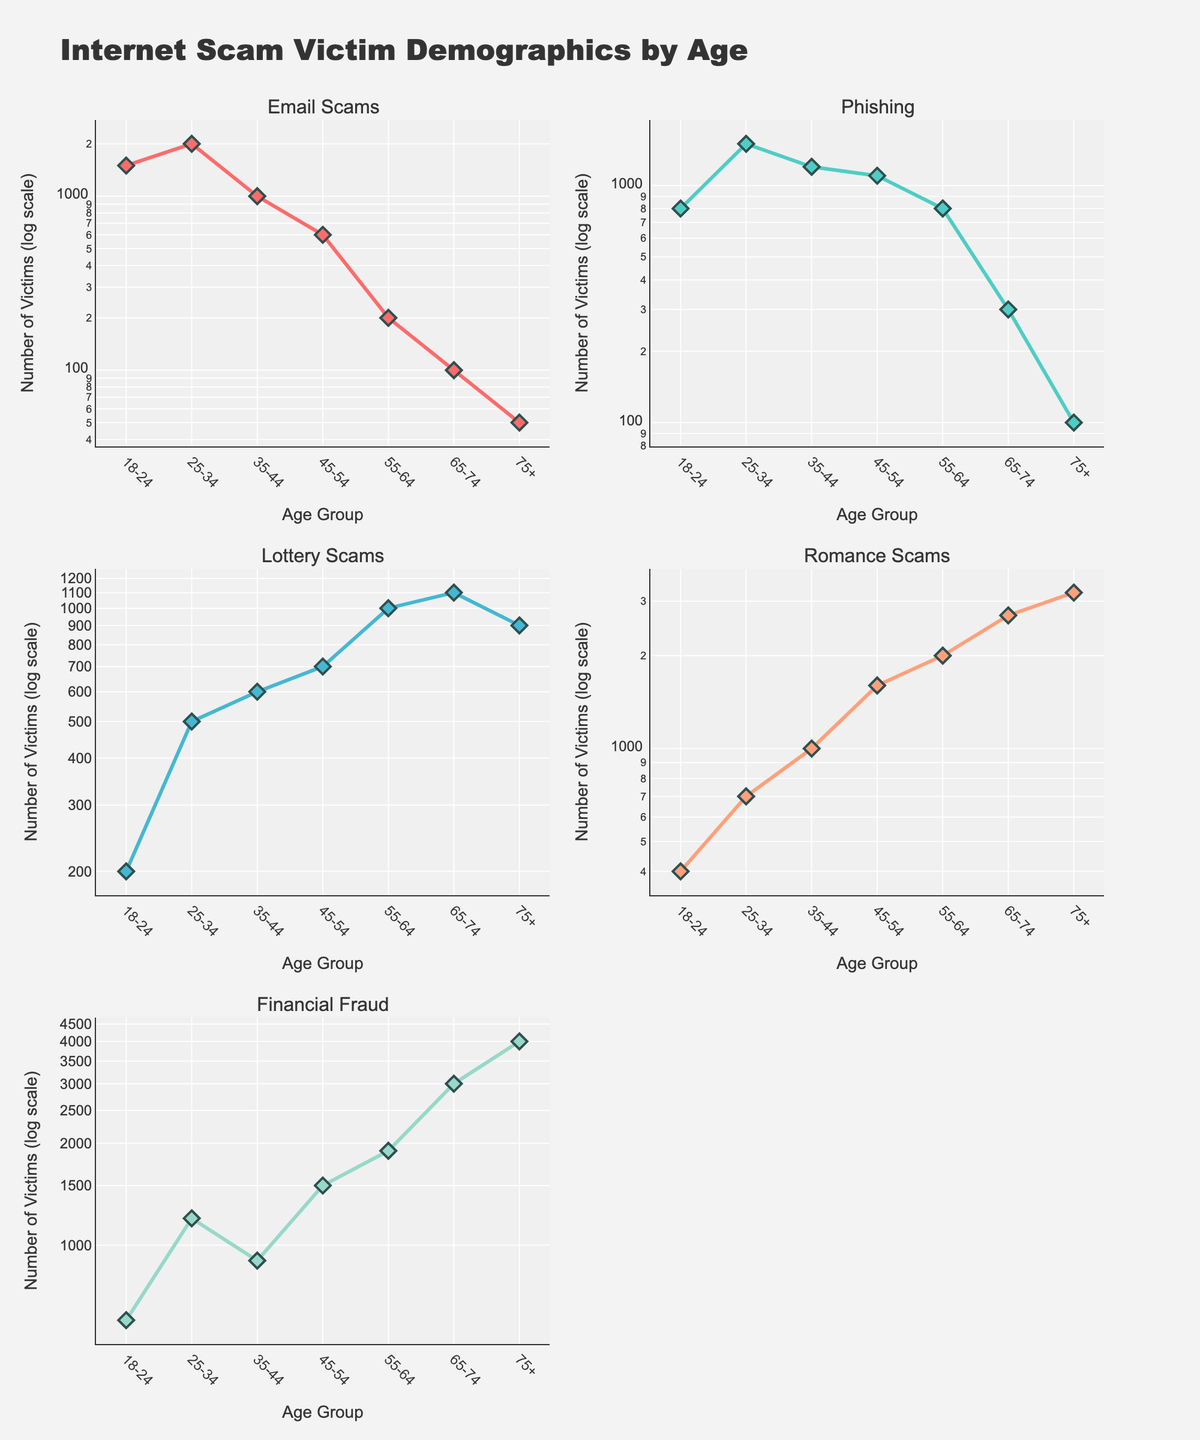What are the age groups displayed in the figure? The x-axis of the figure represents different age groups, which can be read directly: 18-24, 25-34, 35-44, 45-54, 55-64, 65-74, and 75+.
Answer: 18-24, 25-34, 35-44, 45-54, 55-64, 65-74, 75+ Which age group has the highest count of Email Scam victims? By looking at the subplot for Email Scams, we can see the highest y-value corresponds to the 25-34 age group.
Answer: 25-34 What is the log scale value of Financial Fraud victims for the age group 65-74? Locate the subplot for Financial Fraud, find the data point for the age group 65-74, which approximately corresponds to 3000 on the log scale.
Answer: 3000 For which scam type is the number of victims consistently increasing as the age group increases? By examining each subplot, Romance Scams shows a consistent increase in the number of victims as age increases from the 18-24 to the 75+ age group.
Answer: Romance Scams How does the number of victims of Phishing in the 45-54 age group compare to the 55-64 age group? Check the Phishing subplot and compare the y-values for the 45-54 and 55-64 age groups; 45-54 has a slightly higher value.
Answer: 45-54 is higher Which scam type has the least number of victims in the 18-24 age group? Look at each subplot and find the smallest y-value for the 18-24 age group; Lottery Scams has the least number with 200 victims.
Answer: Lottery Scams What is the difference in the number of victims of Romance Scams between the 35-44 and 45-54 age groups? Locate the subplot for Romance Scams, then subtract the y-value for 35-44 (1000) from 45-54 (1600) to get the difference.
Answer: 600 What trend can be observed in Lottery Scams for the age groups 55-64 and 65-74? Observe the Lottery Scams subplot where there is an increase in the number of victims from 55-64 (1000) to 65-74 (1100).
Answer: Increasing Compare the number of Financial Fraud victims between the 55-64 and 75+ age groups. In the Financial Fraud subplot, compare the y-values for 55-64 (1900) and 75+ (4000); 75+ has more victims.
Answer: 75+ is higher Which age group has the highest victim count across all the scam types combined? By summing up the number of victims for each scam type within each age group and comparing, 75+ has the highest total victim count across all scams.
Answer: 75+ 